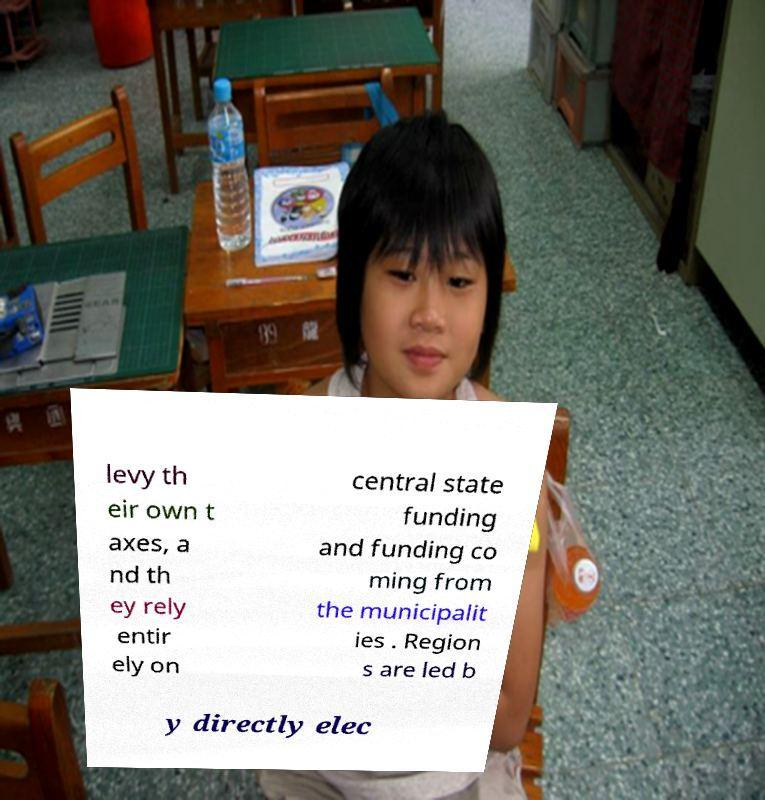I need the written content from this picture converted into text. Can you do that? levy th eir own t axes, a nd th ey rely entir ely on central state funding and funding co ming from the municipalit ies . Region s are led b y directly elec 